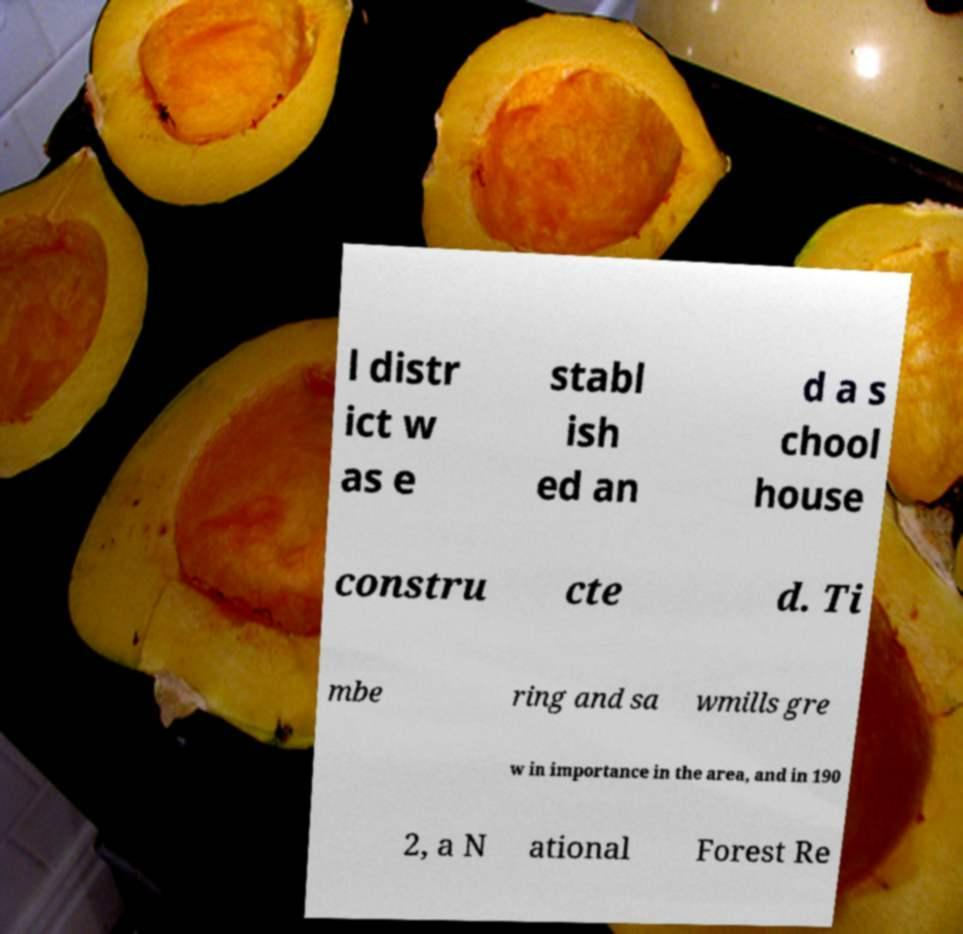Can you accurately transcribe the text from the provided image for me? l distr ict w as e stabl ish ed an d a s chool house constru cte d. Ti mbe ring and sa wmills gre w in importance in the area, and in 190 2, a N ational Forest Re 